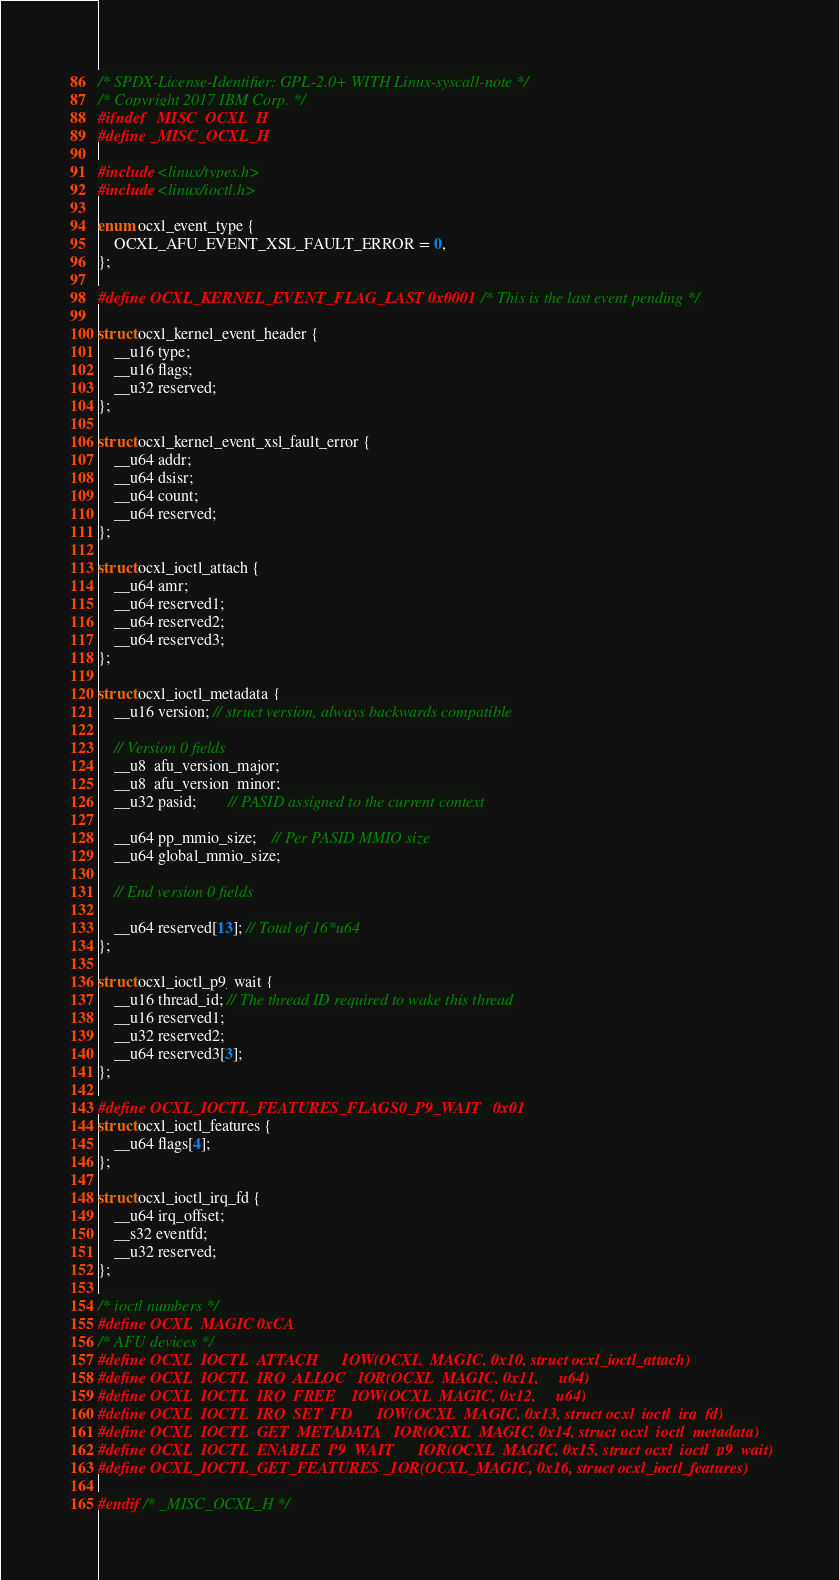Convert code to text. <code><loc_0><loc_0><loc_500><loc_500><_C_>/* SPDX-License-Identifier: GPL-2.0+ WITH Linux-syscall-note */
/* Copyright 2017 IBM Corp. */
#ifndef _MISC_OCXL_H
#define _MISC_OCXL_H

#include <linux/types.h>
#include <linux/ioctl.h>

enum ocxl_event_type {
	OCXL_AFU_EVENT_XSL_FAULT_ERROR = 0,
};

#define OCXL_KERNEL_EVENT_FLAG_LAST 0x0001  /* This is the last event pending */

struct ocxl_kernel_event_header {
	__u16 type;
	__u16 flags;
	__u32 reserved;
};

struct ocxl_kernel_event_xsl_fault_error {
	__u64 addr;
	__u64 dsisr;
	__u64 count;
	__u64 reserved;
};

struct ocxl_ioctl_attach {
	__u64 amr;
	__u64 reserved1;
	__u64 reserved2;
	__u64 reserved3;
};

struct ocxl_ioctl_metadata {
	__u16 version; // struct version, always backwards compatible

	// Version 0 fields
	__u8  afu_version_major;
	__u8  afu_version_minor;
	__u32 pasid;		// PASID assigned to the current context

	__u64 pp_mmio_size;	// Per PASID MMIO size
	__u64 global_mmio_size;

	// End version 0 fields

	__u64 reserved[13]; // Total of 16*u64
};

struct ocxl_ioctl_p9_wait {
	__u16 thread_id; // The thread ID required to wake this thread
	__u16 reserved1;
	__u32 reserved2;
	__u64 reserved3[3];
};

#define OCXL_IOCTL_FEATURES_FLAGS0_P9_WAIT	0x01
struct ocxl_ioctl_features {
	__u64 flags[4];
};

struct ocxl_ioctl_irq_fd {
	__u64 irq_offset;
	__s32 eventfd;
	__u32 reserved;
};

/* ioctl numbers */
#define OCXL_MAGIC 0xCA
/* AFU devices */
#define OCXL_IOCTL_ATTACH	_IOW(OCXL_MAGIC, 0x10, struct ocxl_ioctl_attach)
#define OCXL_IOCTL_IRQ_ALLOC	_IOR(OCXL_MAGIC, 0x11, __u64)
#define OCXL_IOCTL_IRQ_FREE	_IOW(OCXL_MAGIC, 0x12, __u64)
#define OCXL_IOCTL_IRQ_SET_FD	_IOW(OCXL_MAGIC, 0x13, struct ocxl_ioctl_irq_fd)
#define OCXL_IOCTL_GET_METADATA _IOR(OCXL_MAGIC, 0x14, struct ocxl_ioctl_metadata)
#define OCXL_IOCTL_ENABLE_P9_WAIT	_IOR(OCXL_MAGIC, 0x15, struct ocxl_ioctl_p9_wait)
#define OCXL_IOCTL_GET_FEATURES _IOR(OCXL_MAGIC, 0x16, struct ocxl_ioctl_features)

#endif /* _MISC_OCXL_H */
</code> 